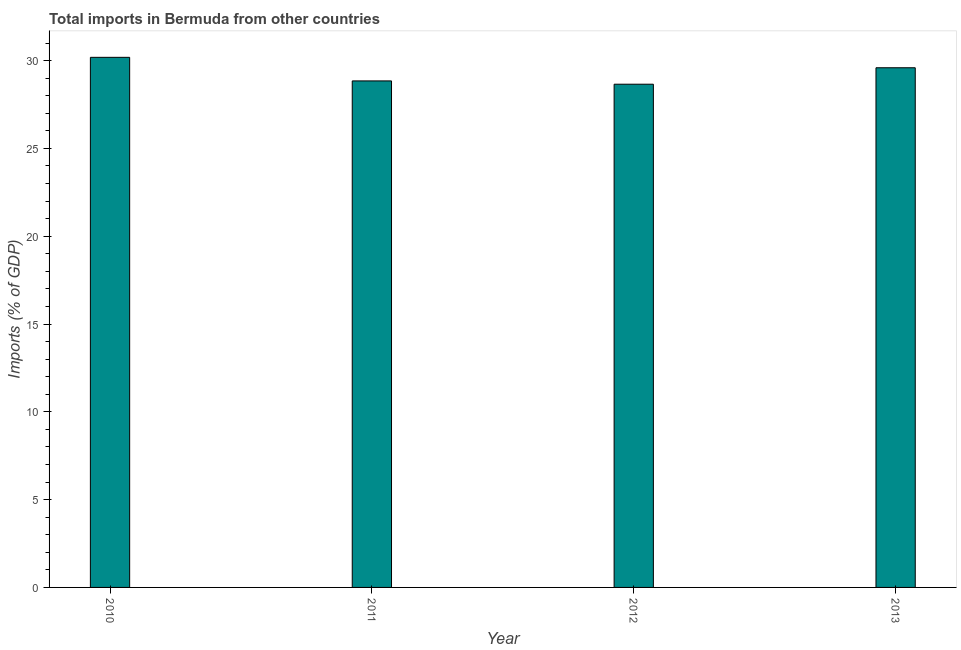Does the graph contain any zero values?
Give a very brief answer. No. What is the title of the graph?
Keep it short and to the point. Total imports in Bermuda from other countries. What is the label or title of the X-axis?
Provide a short and direct response. Year. What is the label or title of the Y-axis?
Provide a succinct answer. Imports (% of GDP). What is the total imports in 2013?
Offer a terse response. 29.59. Across all years, what is the maximum total imports?
Ensure brevity in your answer.  30.19. Across all years, what is the minimum total imports?
Provide a succinct answer. 28.66. In which year was the total imports maximum?
Give a very brief answer. 2010. In which year was the total imports minimum?
Offer a very short reply. 2012. What is the sum of the total imports?
Give a very brief answer. 117.28. What is the difference between the total imports in 2010 and 2013?
Your answer should be compact. 0.59. What is the average total imports per year?
Your answer should be compact. 29.32. What is the median total imports?
Make the answer very short. 29.22. What is the ratio of the total imports in 2011 to that in 2013?
Keep it short and to the point. 0.97. Is the total imports in 2010 less than that in 2012?
Offer a very short reply. No. Is the difference between the total imports in 2010 and 2011 greater than the difference between any two years?
Your answer should be compact. No. What is the difference between the highest and the second highest total imports?
Make the answer very short. 0.59. What is the difference between the highest and the lowest total imports?
Your answer should be very brief. 1.53. Are all the bars in the graph horizontal?
Your answer should be compact. No. How many years are there in the graph?
Give a very brief answer. 4. What is the difference between two consecutive major ticks on the Y-axis?
Keep it short and to the point. 5. Are the values on the major ticks of Y-axis written in scientific E-notation?
Ensure brevity in your answer.  No. What is the Imports (% of GDP) of 2010?
Offer a very short reply. 30.19. What is the Imports (% of GDP) in 2011?
Offer a very short reply. 28.84. What is the Imports (% of GDP) in 2012?
Your answer should be compact. 28.66. What is the Imports (% of GDP) of 2013?
Your answer should be very brief. 29.59. What is the difference between the Imports (% of GDP) in 2010 and 2011?
Make the answer very short. 1.34. What is the difference between the Imports (% of GDP) in 2010 and 2012?
Offer a terse response. 1.53. What is the difference between the Imports (% of GDP) in 2010 and 2013?
Make the answer very short. 0.59. What is the difference between the Imports (% of GDP) in 2011 and 2012?
Your answer should be compact. 0.19. What is the difference between the Imports (% of GDP) in 2011 and 2013?
Your response must be concise. -0.75. What is the difference between the Imports (% of GDP) in 2012 and 2013?
Your response must be concise. -0.94. What is the ratio of the Imports (% of GDP) in 2010 to that in 2011?
Ensure brevity in your answer.  1.05. What is the ratio of the Imports (% of GDP) in 2010 to that in 2012?
Your answer should be very brief. 1.05. What is the ratio of the Imports (% of GDP) in 2011 to that in 2013?
Your response must be concise. 0.97. 